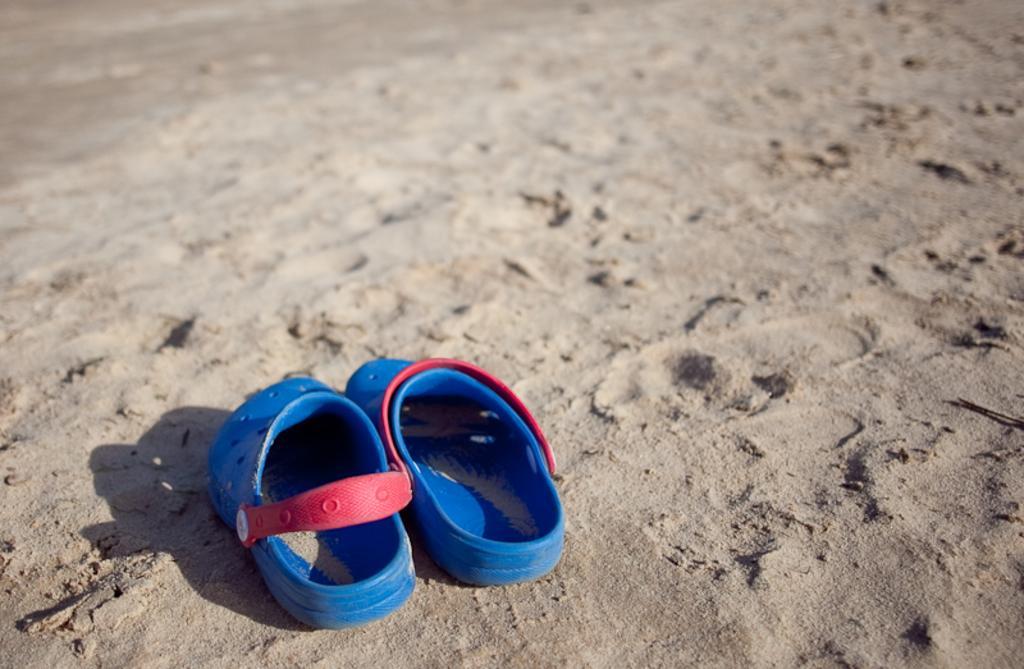In one or two sentences, can you explain what this image depicts? In this picture we can see blue color slippers, at the bottom there is sand. 